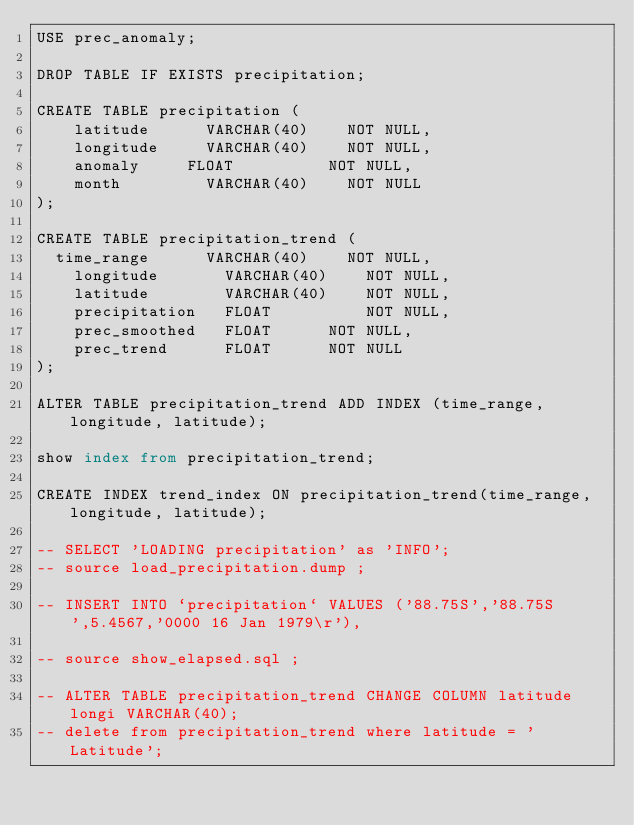<code> <loc_0><loc_0><loc_500><loc_500><_SQL_>USE prec_anomaly;

DROP TABLE IF EXISTS precipitation;

CREATE TABLE precipitation (
    latitude      VARCHAR(40)    NOT NULL,
    longitude  	  VARCHAR(40)    NOT NULL,
    anomaly  	  FLOAT          NOT NULL,
    month         VARCHAR(40)    NOT NULL
);

CREATE TABLE precipitation_trend (
	time_range      VARCHAR(40)    NOT NULL,
    longitude  	  	VARCHAR(40)    NOT NULL,
    latitude      	VARCHAR(40)    NOT NULL,
    precipitation  	FLOAT          NOT NULL,
    prec_smoothed   FLOAT		   NOT NULL,
    prec_trend      FLOAT		   NOT NULL
);

ALTER TABLE precipitation_trend ADD INDEX (time_range, longitude, latitude);

show index from precipitation_trend;

CREATE INDEX trend_index ON precipitation_trend(time_range, longitude, latitude);

-- SELECT 'LOADING precipitation' as 'INFO';
-- source load_precipitation.dump ;

-- INSERT INTO `precipitation` VALUES ('88.75S','88.75S',5.4567,'0000 16 Jan 1979\r'),

-- source show_elapsed.sql ;

-- ALTER TABLE precipitation_trend CHANGE COLUMN latitude longi VARCHAR(40);
-- delete from precipitation_trend where latitude = 'Latitude';</code> 